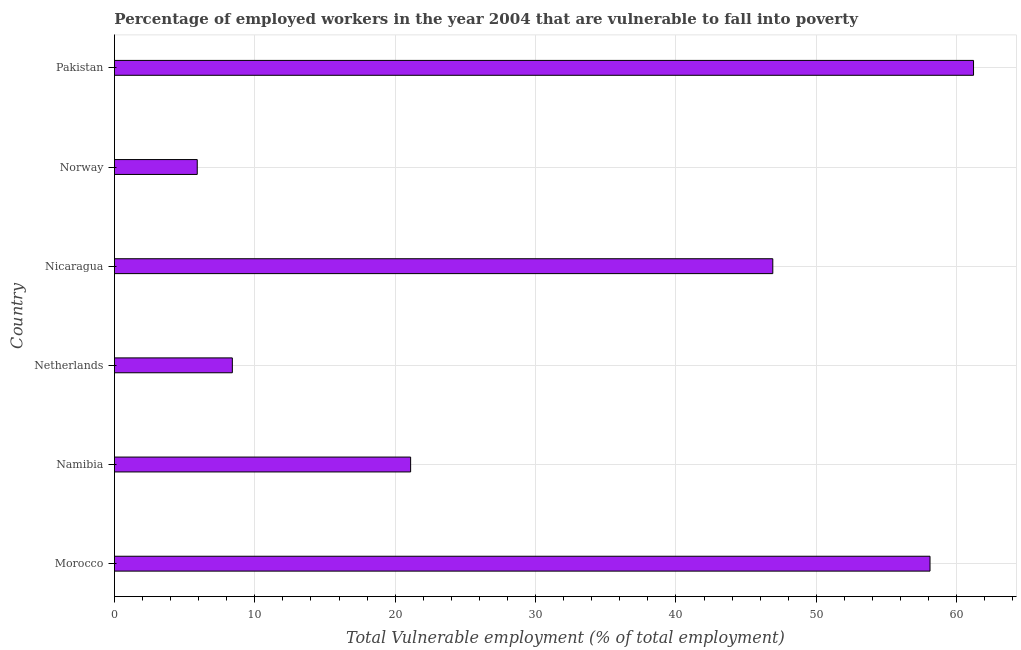What is the title of the graph?
Provide a succinct answer. Percentage of employed workers in the year 2004 that are vulnerable to fall into poverty. What is the label or title of the X-axis?
Your answer should be compact. Total Vulnerable employment (% of total employment). What is the total vulnerable employment in Nicaragua?
Provide a succinct answer. 46.9. Across all countries, what is the maximum total vulnerable employment?
Your response must be concise. 61.2. Across all countries, what is the minimum total vulnerable employment?
Your response must be concise. 5.9. In which country was the total vulnerable employment minimum?
Provide a short and direct response. Norway. What is the sum of the total vulnerable employment?
Ensure brevity in your answer.  201.6. What is the difference between the total vulnerable employment in Morocco and Pakistan?
Offer a very short reply. -3.1. What is the average total vulnerable employment per country?
Offer a very short reply. 33.6. What is the median total vulnerable employment?
Provide a succinct answer. 34. What is the ratio of the total vulnerable employment in Namibia to that in Netherlands?
Provide a succinct answer. 2.51. Is the difference between the total vulnerable employment in Morocco and Netherlands greater than the difference between any two countries?
Your answer should be very brief. No. Is the sum of the total vulnerable employment in Morocco and Nicaragua greater than the maximum total vulnerable employment across all countries?
Keep it short and to the point. Yes. What is the difference between the highest and the lowest total vulnerable employment?
Give a very brief answer. 55.3. How many bars are there?
Offer a very short reply. 6. Are all the bars in the graph horizontal?
Ensure brevity in your answer.  Yes. How many countries are there in the graph?
Make the answer very short. 6. What is the difference between two consecutive major ticks on the X-axis?
Ensure brevity in your answer.  10. What is the Total Vulnerable employment (% of total employment) of Morocco?
Your answer should be very brief. 58.1. What is the Total Vulnerable employment (% of total employment) of Namibia?
Give a very brief answer. 21.1. What is the Total Vulnerable employment (% of total employment) in Netherlands?
Give a very brief answer. 8.4. What is the Total Vulnerable employment (% of total employment) of Nicaragua?
Your answer should be very brief. 46.9. What is the Total Vulnerable employment (% of total employment) in Norway?
Provide a short and direct response. 5.9. What is the Total Vulnerable employment (% of total employment) of Pakistan?
Keep it short and to the point. 61.2. What is the difference between the Total Vulnerable employment (% of total employment) in Morocco and Netherlands?
Offer a terse response. 49.7. What is the difference between the Total Vulnerable employment (% of total employment) in Morocco and Nicaragua?
Keep it short and to the point. 11.2. What is the difference between the Total Vulnerable employment (% of total employment) in Morocco and Norway?
Provide a short and direct response. 52.2. What is the difference between the Total Vulnerable employment (% of total employment) in Namibia and Netherlands?
Make the answer very short. 12.7. What is the difference between the Total Vulnerable employment (% of total employment) in Namibia and Nicaragua?
Keep it short and to the point. -25.8. What is the difference between the Total Vulnerable employment (% of total employment) in Namibia and Pakistan?
Make the answer very short. -40.1. What is the difference between the Total Vulnerable employment (% of total employment) in Netherlands and Nicaragua?
Your answer should be compact. -38.5. What is the difference between the Total Vulnerable employment (% of total employment) in Netherlands and Pakistan?
Your answer should be very brief. -52.8. What is the difference between the Total Vulnerable employment (% of total employment) in Nicaragua and Norway?
Give a very brief answer. 41. What is the difference between the Total Vulnerable employment (% of total employment) in Nicaragua and Pakistan?
Your answer should be very brief. -14.3. What is the difference between the Total Vulnerable employment (% of total employment) in Norway and Pakistan?
Offer a terse response. -55.3. What is the ratio of the Total Vulnerable employment (% of total employment) in Morocco to that in Namibia?
Give a very brief answer. 2.75. What is the ratio of the Total Vulnerable employment (% of total employment) in Morocco to that in Netherlands?
Your response must be concise. 6.92. What is the ratio of the Total Vulnerable employment (% of total employment) in Morocco to that in Nicaragua?
Provide a succinct answer. 1.24. What is the ratio of the Total Vulnerable employment (% of total employment) in Morocco to that in Norway?
Your response must be concise. 9.85. What is the ratio of the Total Vulnerable employment (% of total employment) in Morocco to that in Pakistan?
Offer a terse response. 0.95. What is the ratio of the Total Vulnerable employment (% of total employment) in Namibia to that in Netherlands?
Provide a succinct answer. 2.51. What is the ratio of the Total Vulnerable employment (% of total employment) in Namibia to that in Nicaragua?
Offer a terse response. 0.45. What is the ratio of the Total Vulnerable employment (% of total employment) in Namibia to that in Norway?
Keep it short and to the point. 3.58. What is the ratio of the Total Vulnerable employment (% of total employment) in Namibia to that in Pakistan?
Your response must be concise. 0.34. What is the ratio of the Total Vulnerable employment (% of total employment) in Netherlands to that in Nicaragua?
Offer a terse response. 0.18. What is the ratio of the Total Vulnerable employment (% of total employment) in Netherlands to that in Norway?
Keep it short and to the point. 1.42. What is the ratio of the Total Vulnerable employment (% of total employment) in Netherlands to that in Pakistan?
Give a very brief answer. 0.14. What is the ratio of the Total Vulnerable employment (% of total employment) in Nicaragua to that in Norway?
Offer a terse response. 7.95. What is the ratio of the Total Vulnerable employment (% of total employment) in Nicaragua to that in Pakistan?
Your answer should be compact. 0.77. What is the ratio of the Total Vulnerable employment (% of total employment) in Norway to that in Pakistan?
Make the answer very short. 0.1. 